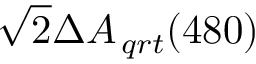Convert formula to latex. <formula><loc_0><loc_0><loc_500><loc_500>\sqrt { 2 } \Delta { { A _ { \, q r t } } ( 4 8 0 ) }</formula> 